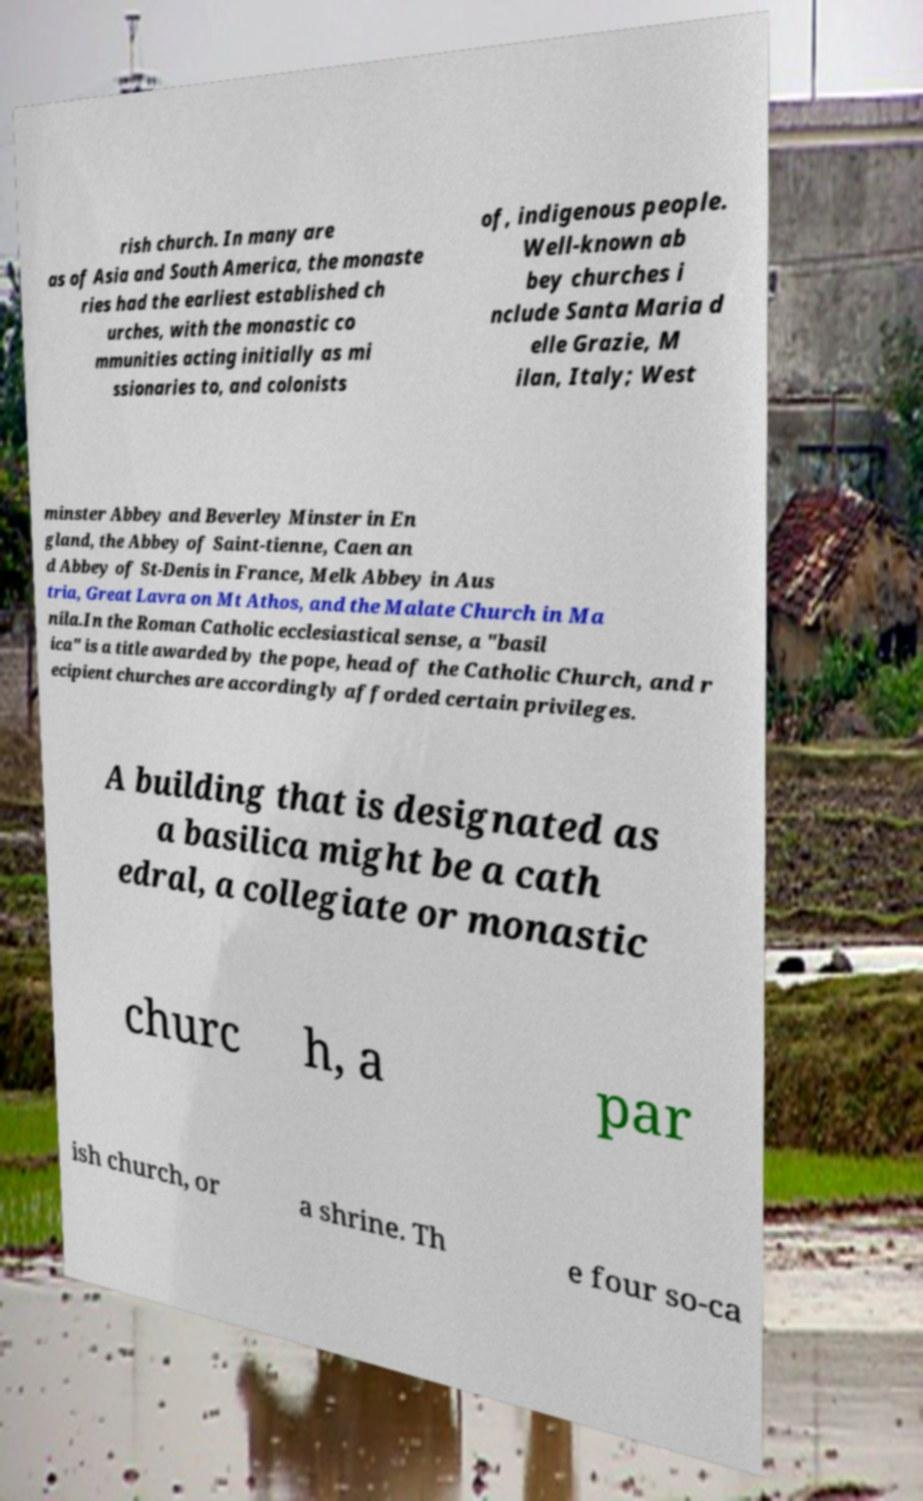Could you extract and type out the text from this image? rish church. In many are as of Asia and South America, the monaste ries had the earliest established ch urches, with the monastic co mmunities acting initially as mi ssionaries to, and colonists of, indigenous people. Well-known ab bey churches i nclude Santa Maria d elle Grazie, M ilan, Italy; West minster Abbey and Beverley Minster in En gland, the Abbey of Saint-tienne, Caen an d Abbey of St-Denis in France, Melk Abbey in Aus tria, Great Lavra on Mt Athos, and the Malate Church in Ma nila.In the Roman Catholic ecclesiastical sense, a "basil ica" is a title awarded by the pope, head of the Catholic Church, and r ecipient churches are accordingly afforded certain privileges. A building that is designated as a basilica might be a cath edral, a collegiate or monastic churc h, a par ish church, or a shrine. Th e four so-ca 